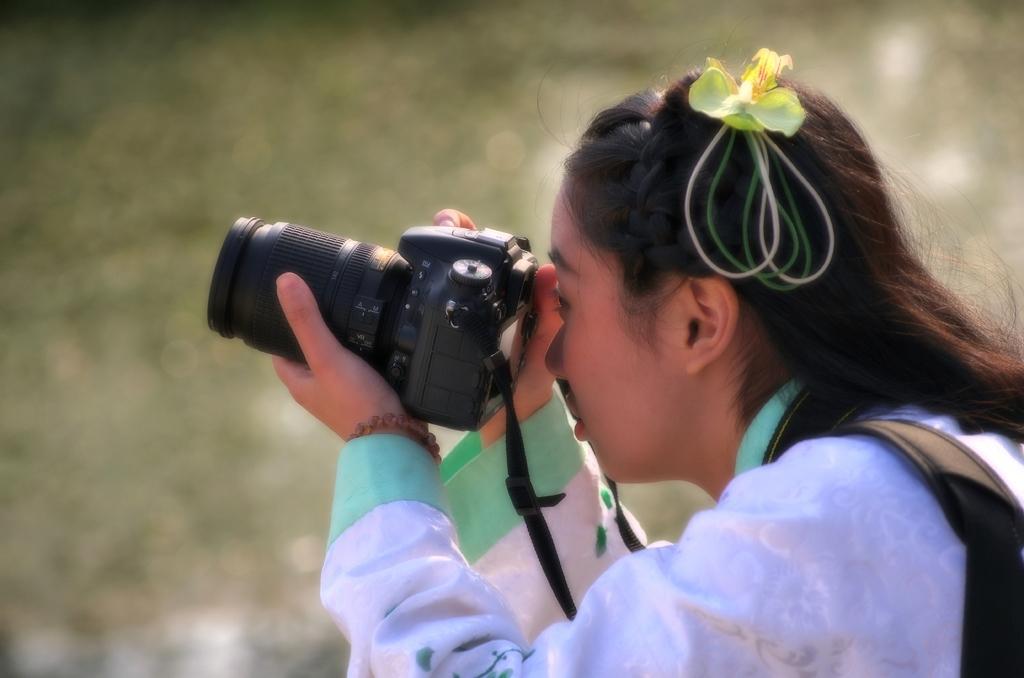Could you give a brief overview of what you see in this image? In this image the woman is holding a camera. 